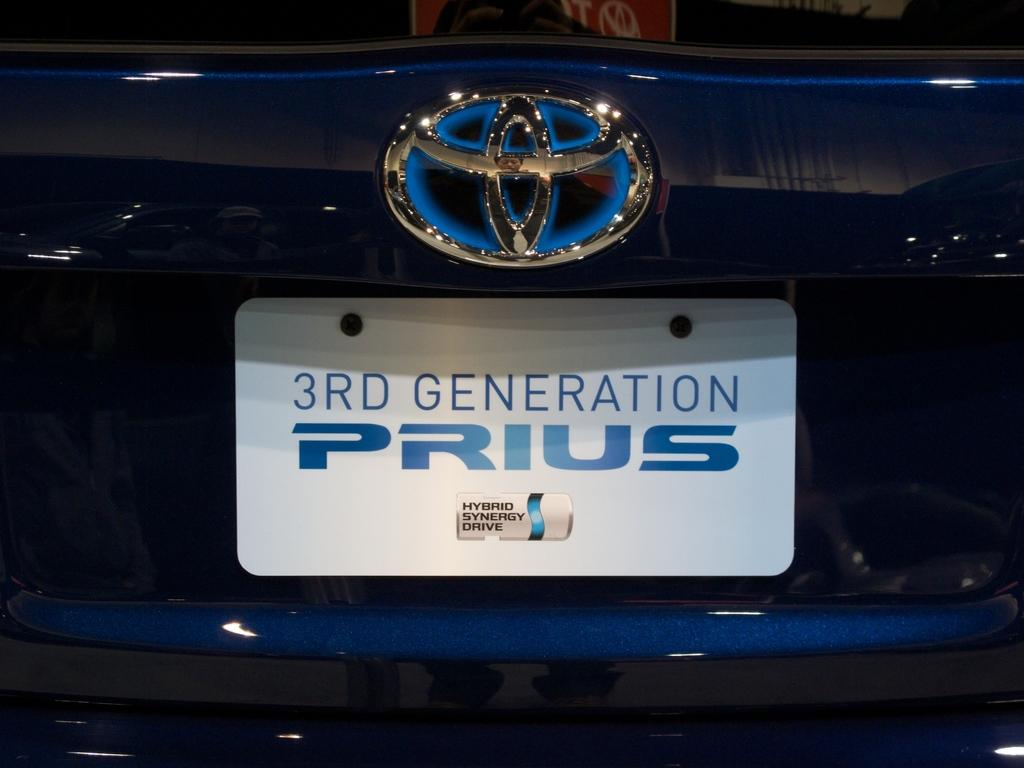<image>
Describe the image concisely. A close up shot of the rear of a blue 3rd generation prius. 